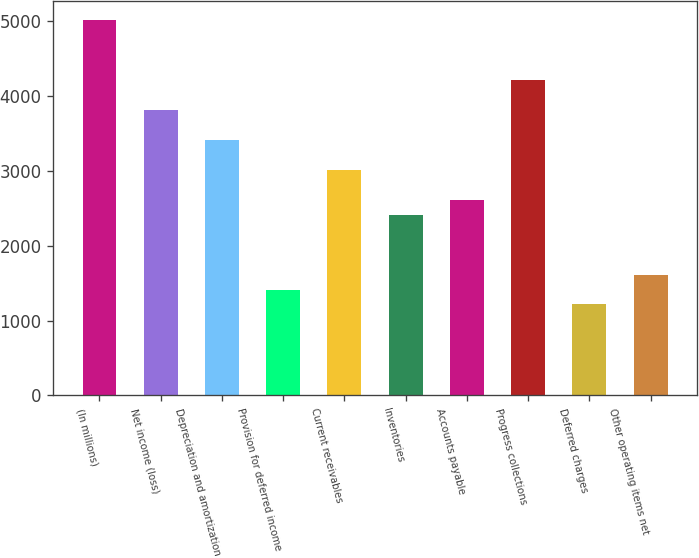Convert chart. <chart><loc_0><loc_0><loc_500><loc_500><bar_chart><fcel>(In millions)<fcel>Net income (loss)<fcel>Depreciation and amortization<fcel>Provision for deferred income<fcel>Current receivables<fcel>Inventories<fcel>Accounts payable<fcel>Progress collections<fcel>Deferred charges<fcel>Other operating items net<nl><fcel>5013.5<fcel>3814.1<fcel>3414.3<fcel>1415.3<fcel>3014.5<fcel>2414.8<fcel>2614.7<fcel>4213.9<fcel>1215.4<fcel>1615.2<nl></chart> 